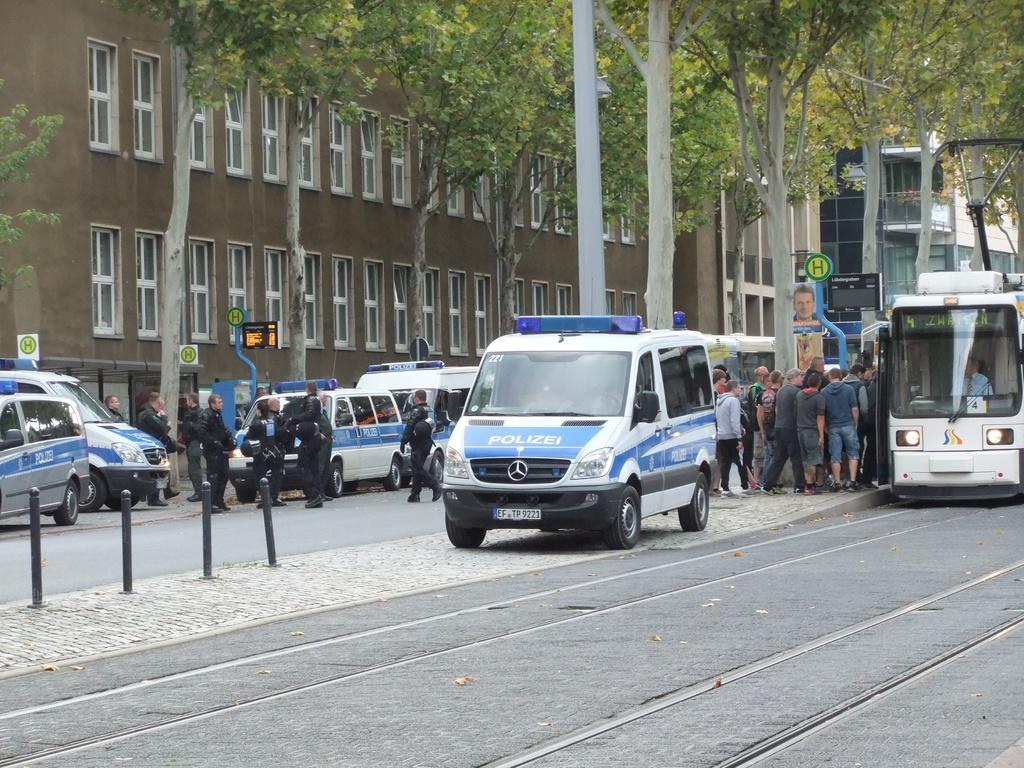<image>
Create a compact narrative representing the image presented. A blue and white van with Polizei painted on its hood. 